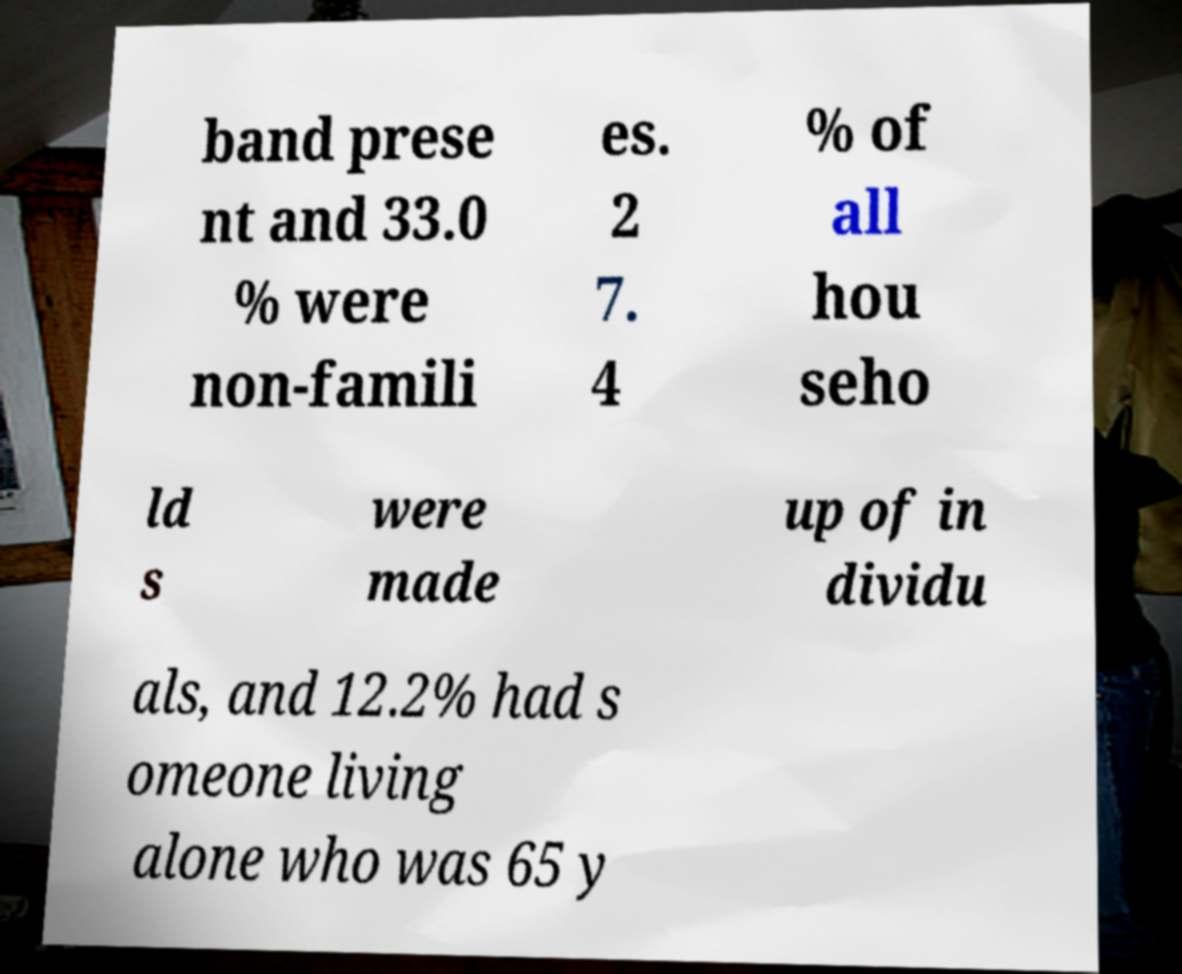Please identify and transcribe the text found in this image. band prese nt and 33.0 % were non-famili es. 2 7. 4 % of all hou seho ld s were made up of in dividu als, and 12.2% had s omeone living alone who was 65 y 